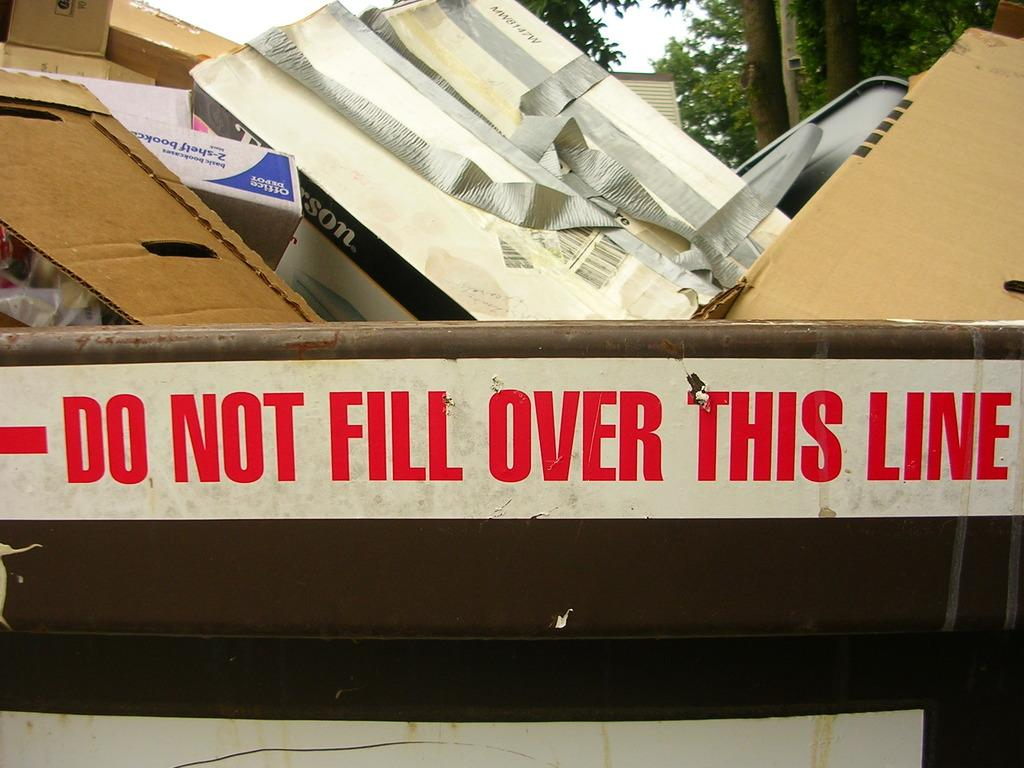<image>
Write a terse but informative summary of the picture. A trash bin is full of boxes and says Do not fill over this line. 